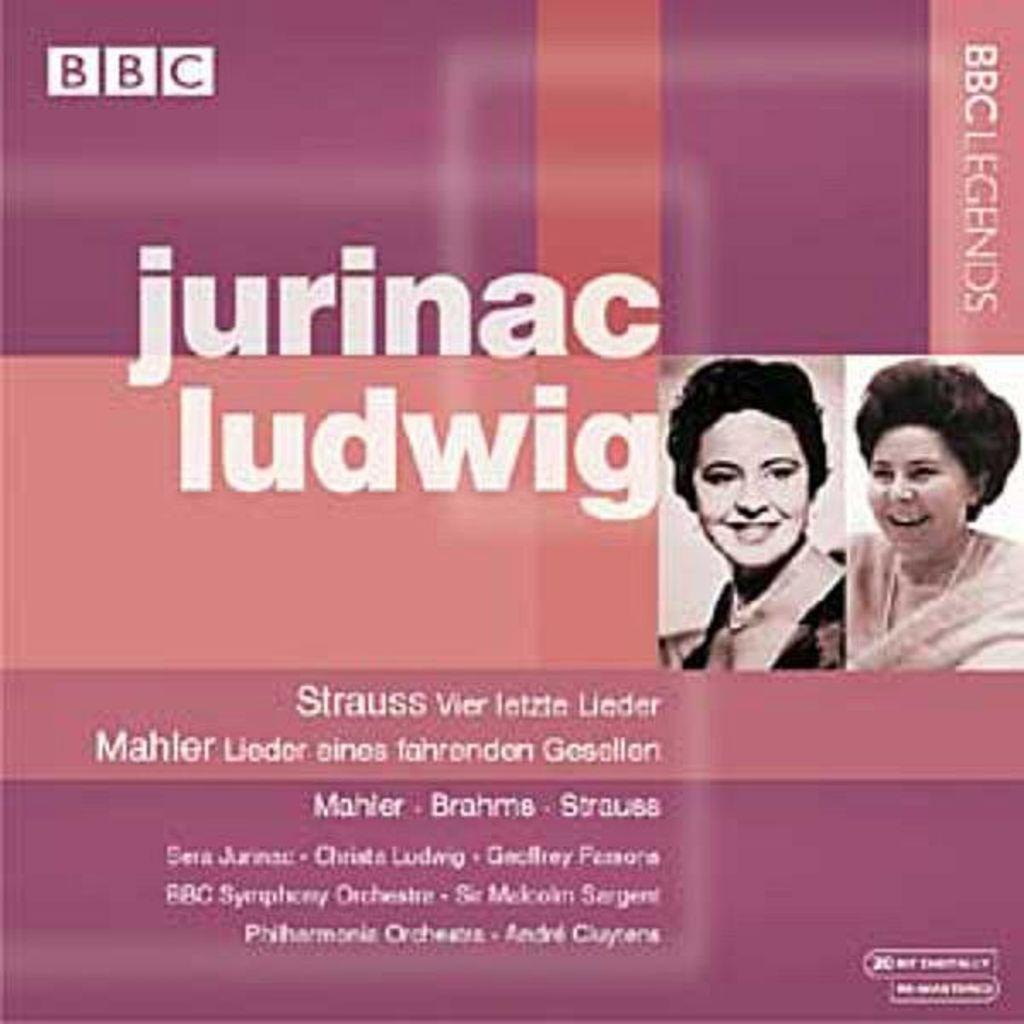What type of content is the image promoting? The image is an advertisement. What can be seen on the right side of the image? There are pictures of two ladies on the right side of the image. What else is present in the image besides the pictures of the ladies? There is text in the image. What type of pot is being used by the ladies in the image? There is no pot visible in the image, and the ladies are not using any pot. Can you describe the locket worn by the ladies in the image? There is no locket visible in the image, and the ladies are not wearing any locket. 